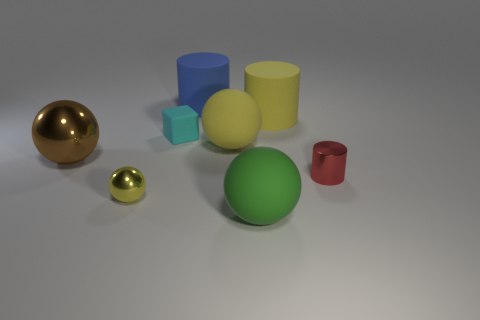There is a object that is both to the right of the small yellow thing and in front of the small cylinder; what is its shape?
Your answer should be very brief. Sphere. The other metallic thing that is the same shape as the large blue thing is what size?
Keep it short and to the point. Small. Are there fewer big shiny objects to the right of the cyan cube than matte cylinders?
Your answer should be compact. Yes. There is a sphere left of the small yellow sphere; how big is it?
Ensure brevity in your answer.  Large. What is the color of the tiny metallic thing that is the same shape as the large brown metal thing?
Your answer should be very brief. Yellow. How many big metallic spheres have the same color as the tiny shiny cylinder?
Your response must be concise. 0. Is there anything else that has the same shape as the yellow shiny thing?
Your response must be concise. Yes. There is a large yellow rubber cylinder that is behind the yellow object that is to the left of the large blue rubber object; is there a shiny object to the right of it?
Make the answer very short. Yes. What number of large green spheres are the same material as the red cylinder?
Your response must be concise. 0. Do the metal thing that is on the right side of the yellow rubber cylinder and the rubber ball that is behind the big brown ball have the same size?
Ensure brevity in your answer.  No. 